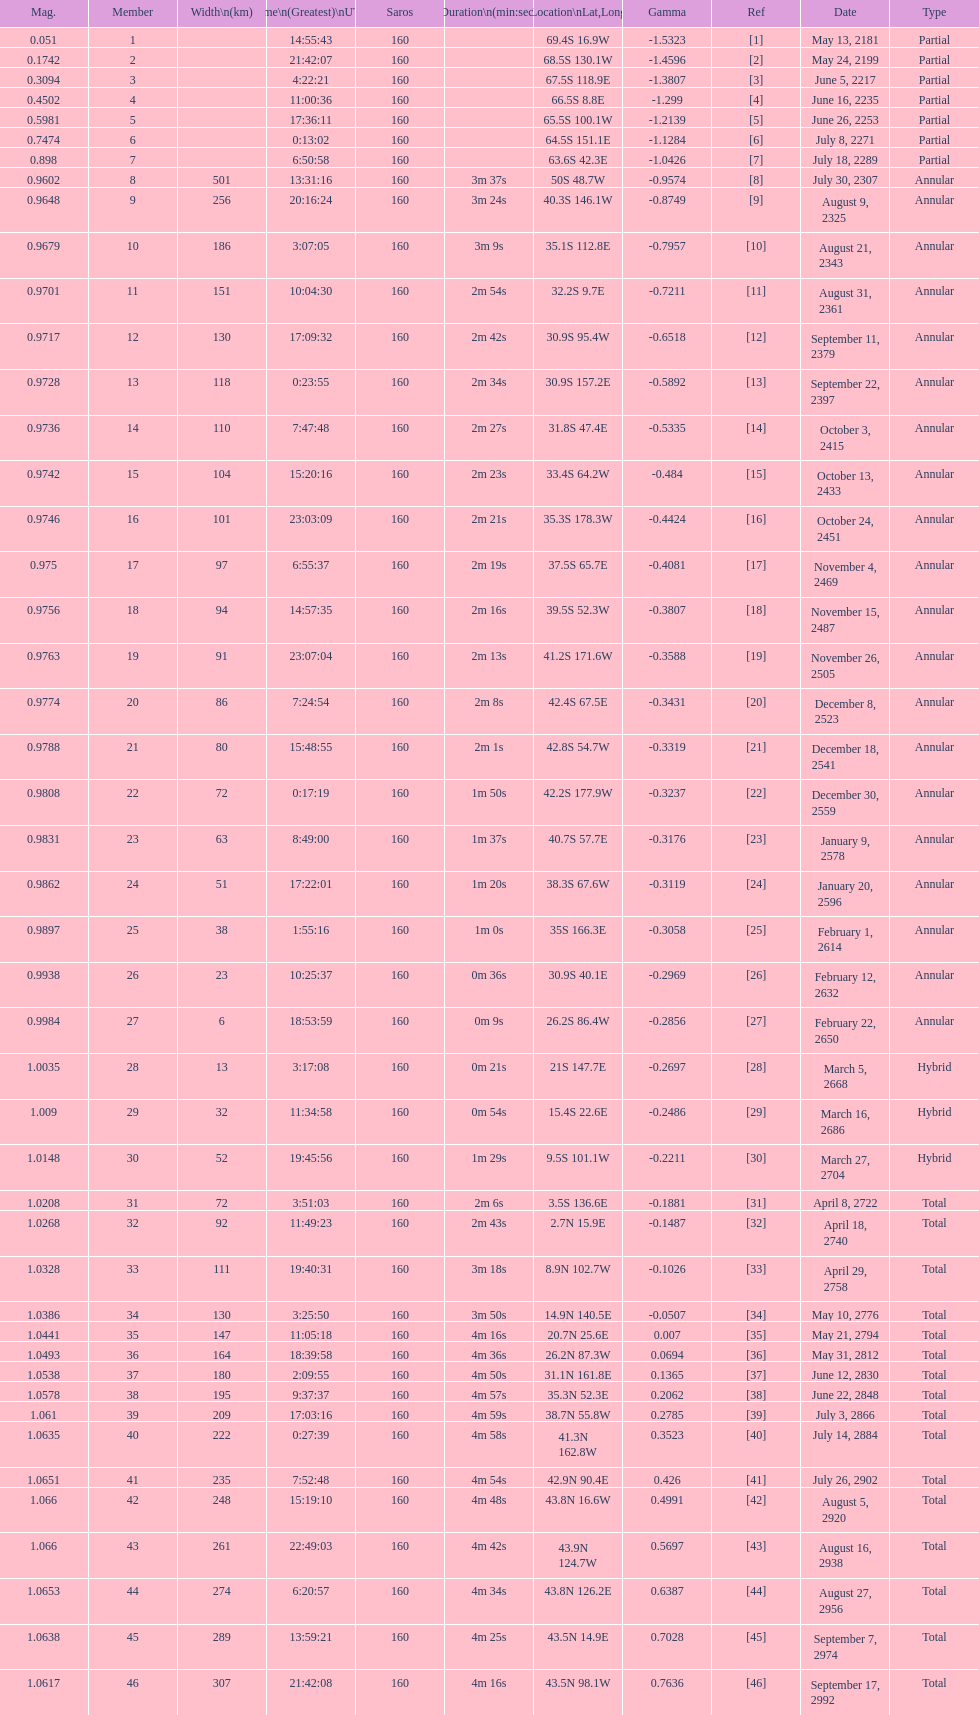Name one that has the same latitude as member number 12. 13. 